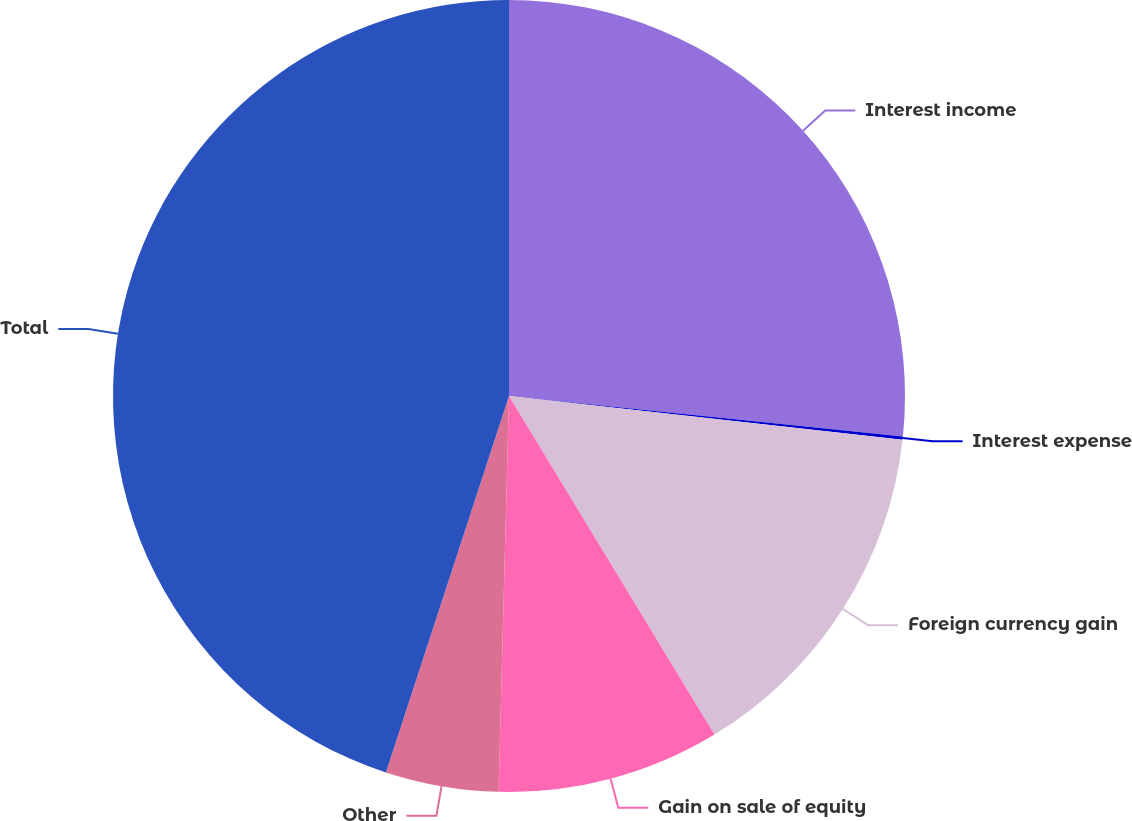Convert chart. <chart><loc_0><loc_0><loc_500><loc_500><pie_chart><fcel>Interest income<fcel>Interest expense<fcel>Foreign currency gain<fcel>Gain on sale of equity<fcel>Other<fcel>Total<nl><fcel>26.63%<fcel>0.13%<fcel>14.56%<fcel>9.1%<fcel>4.61%<fcel>44.97%<nl></chart> 